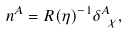<formula> <loc_0><loc_0><loc_500><loc_500>n ^ { A } = R ( \eta ) ^ { - 1 } \delta ^ { A } _ { \ \chi } ,</formula> 